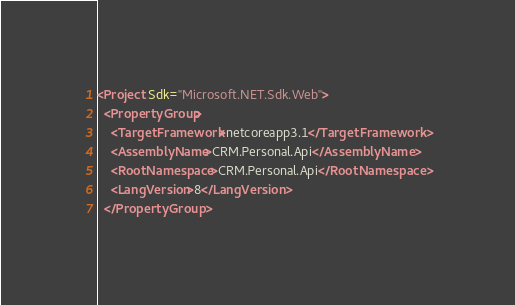Convert code to text. <code><loc_0><loc_0><loc_500><loc_500><_XML_><Project Sdk="Microsoft.NET.Sdk.Web">
  <PropertyGroup>
    <TargetFramework>netcoreapp3.1</TargetFramework>
    <AssemblyName>CRM.Personal.Api</AssemblyName>
    <RootNamespace>CRM.Personal.Api</RootNamespace>
    <LangVersion>8</LangVersion>
  </PropertyGroup></code> 